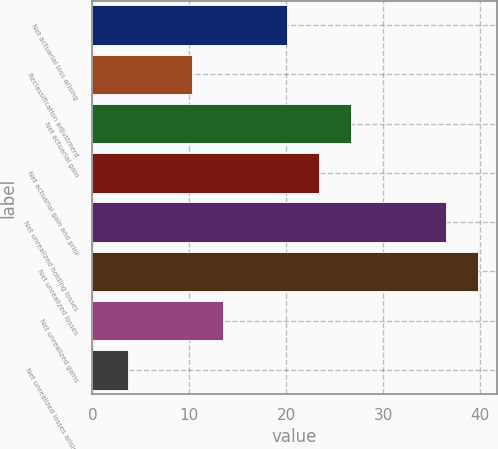Convert chart. <chart><loc_0><loc_0><loc_500><loc_500><bar_chart><fcel>Net actuarial loss arising<fcel>Reclassification adjustment<fcel>Net actuarial gain<fcel>Net actuarial gain and prior<fcel>Net unrealized holding losses<fcel>Net unrealized losses<fcel>Net unrealized gains<fcel>Net unrealized losses arising<nl><fcel>20.08<fcel>10.24<fcel>26.64<fcel>23.36<fcel>36.48<fcel>39.76<fcel>13.52<fcel>3.68<nl></chart> 